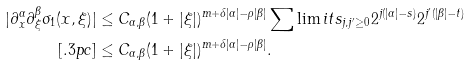Convert formula to latex. <formula><loc_0><loc_0><loc_500><loc_500>| \partial ^ { \alpha } _ { x } \partial ^ { \beta } _ { \xi } \sigma _ { 1 } ( x , \xi ) | & \leq C _ { \alpha , \beta } ( 1 + | \xi | ) ^ { m + \delta | \alpha | - \rho | \beta | } \sum \lim i t s _ { j , j ^ { \prime } \geq 0 } 2 ^ { j ( | \alpha | - s ) } 2 ^ { j ^ { \prime } ( | \beta | - t ) } \\ [ . 3 p c ] & \leq C _ { \alpha , \beta } ( 1 + | \xi | ) ^ { m + \delta | \alpha | - \rho | \beta | } .</formula> 